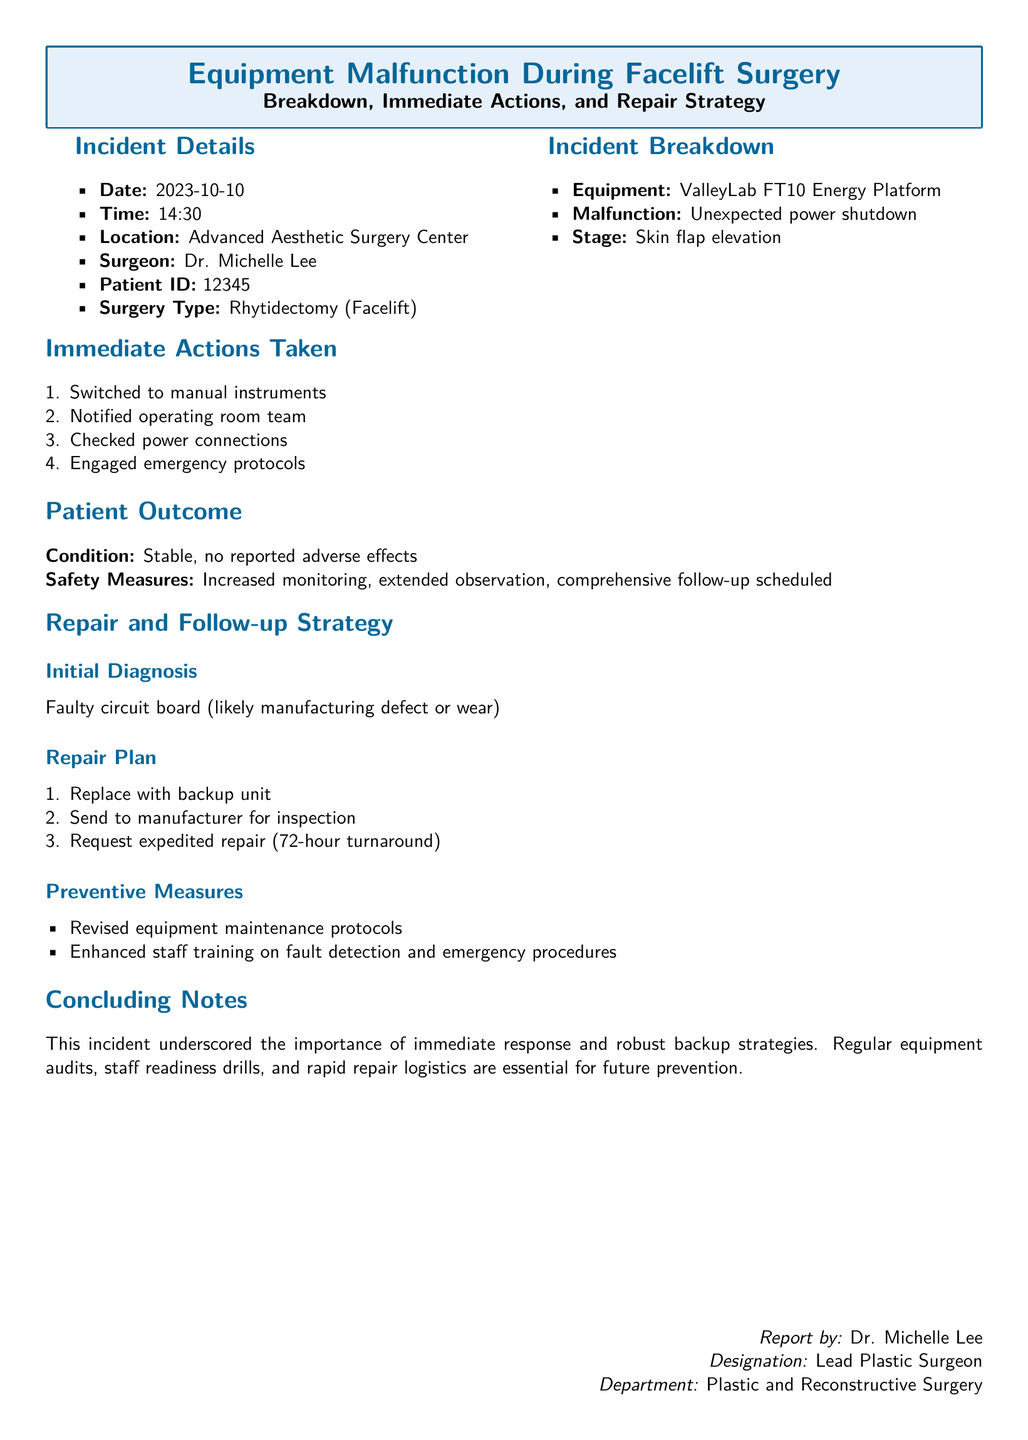What was the date of the incident? The incident occurred on October 10, 2023, which is indicated in the incident details.
Answer: 2023-10-10 What type of surgery was performed? The type of surgery mentioned in the document is Rhytidectomy, commonly known as a facelift.
Answer: Rhytidectomy (Facelift) What equipment malfunctioned during the surgery? The equipment that malfunctioned is specified as the ValleyLab FT10 Energy Platform.
Answer: ValleyLab FT10 Energy Platform What immediate action was taken after the equipment failed? The first immediate action mentioned was switching to manual instruments.
Answer: Switched to manual instruments What was the patient's condition after the incident? The document states that the patient's condition was stable with no reported adverse effects.
Answer: Stable, no reported adverse effects What can be inferred about the repair strategy for the malfunction? The repair strategy includes replacing the unit with a backup, indicating a proactive approach to equipment issues.
Answer: Replace with backup unit How long is the turnaround time for the expedited repair? The document specifies that the requested expedited repair has a turnaround time of 72 hours.
Answer: 72-hour turnaround What preventive measures were recommended after the incident? The document outlines revised equipment maintenance protocols as one of the preventive measures.
Answer: Revised equipment maintenance protocols 